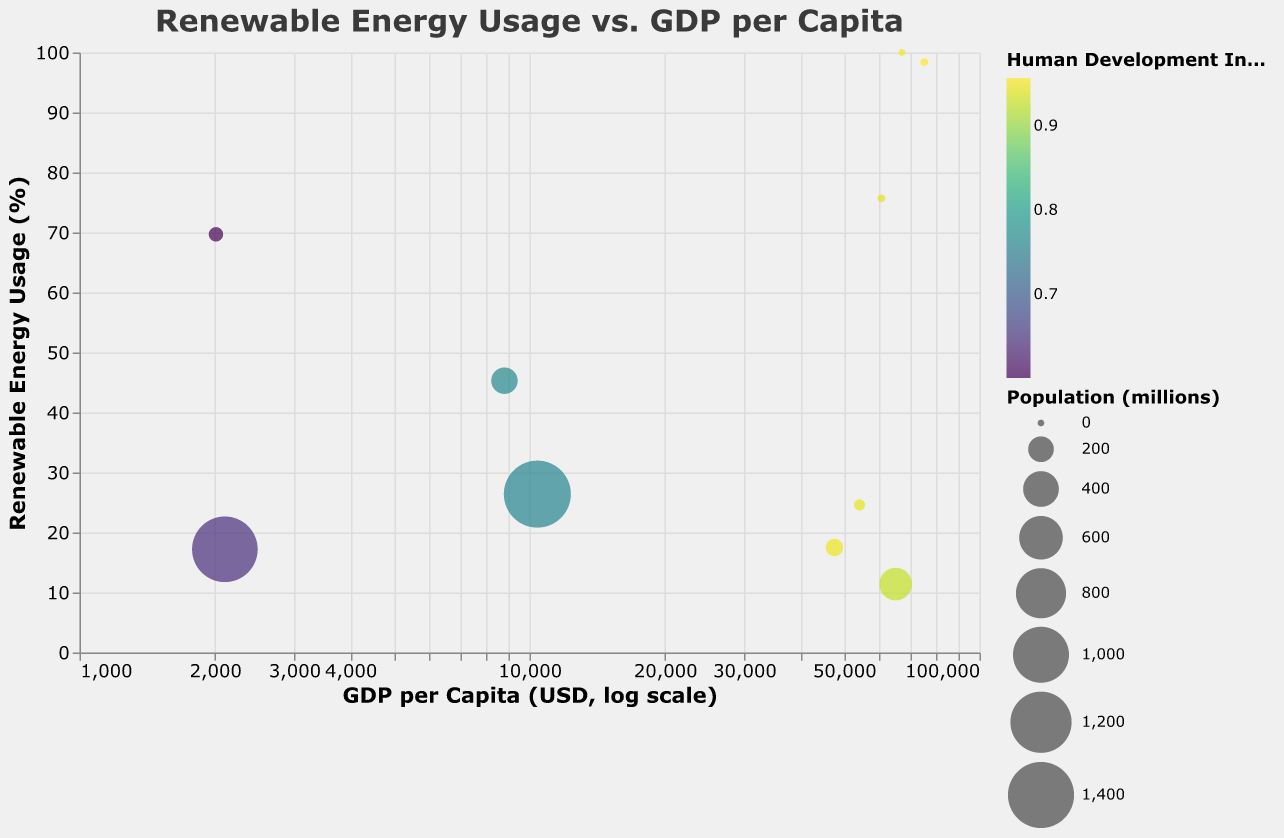What is the title of the chart? The title of the chart is displayed at the top and is written in large font to grab attention.
Answer: Renewable Energy Usage vs. GDP per Capita What does the size of a bubble represent? The size of each bubble corresponds to the population of the respective country, with larger bubbles indicating larger populations.
Answer: Population Which country has the highest renewable energy usage? The bubbles on the chart represent different countries, and the highest point on the y-axis corresponds to the country with the highest renewable energy usage.
Answer: Iceland What country has the smallest bubble and what does it represent? The smallest bubble can be identified visually as the tiny dot among the larger bubbles, and it represents Iceland, indicating its relatively low population.
Answer: Iceland Which country has the highest GDP per capita and how is it represented on the chart? The highest GDP per capita can be found on the far right side of the x-axis, and the country represented there is Norway.
Answer: Norway What is the Human Development Index (HDI) range depicted in the color scale? The chart uses a color gradient to denote the range of HDI values, ranging from lower to higher indices. By looking at the color legend, we can identify the endpoints of the scale.
Answer: Approximately 0.60 to 0.96 Compare the renewable energy usage between Australia and China. Locate the bubbles representing Australia and China and compare their positions on the y-axis. Australia's bubble is higher, indicating greater renewable energy usage.
Answer: Australia has higher renewable energy usage than China Which country with a population over 300 million has the lowest renewable energy usage? Look for the largest bubbles, which represent countries with populations over 300 million, and identify the one with the lowest position on the y-axis.
Answer: United States How does the GDP per capita of Denmark compare to that of Germany? Find the bubbles representing Denmark and Germany. Compare their positions on the x-axis where Denmark's position is slightly to the right of Germany, indicating a higher GDP per capita.
Answer: Denmark has a higher GDP per capita than Germany What trend can be observed between GDP per capita and renewable energy usage for the countries shown? Observe the general distribution of bubbles along the x and y axes to identify any visible patterns. A general trend is that countries with very high GDP per capita (e.g., Norway, Iceland) tend to have high renewable energy usage, although there are exceptions.
Answer: Higher GDP per capita can coincide with high renewable energy usage but is not a strict rule 